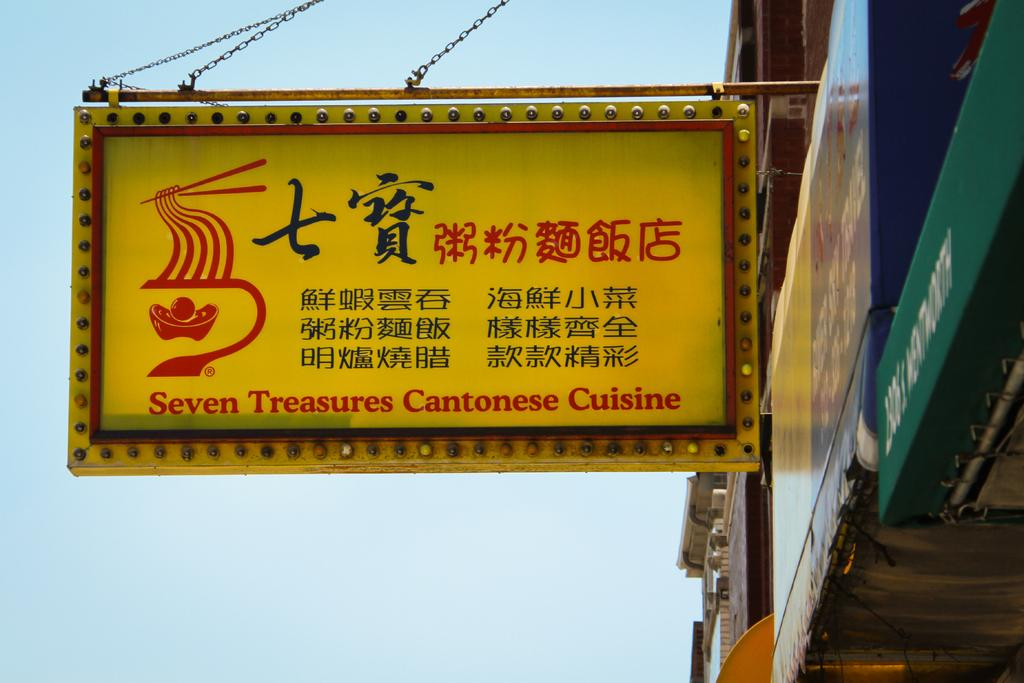<image>
Provide a brief description of the given image. a sign outside a building that says 'seven treasures cantonese cuisine' on it 